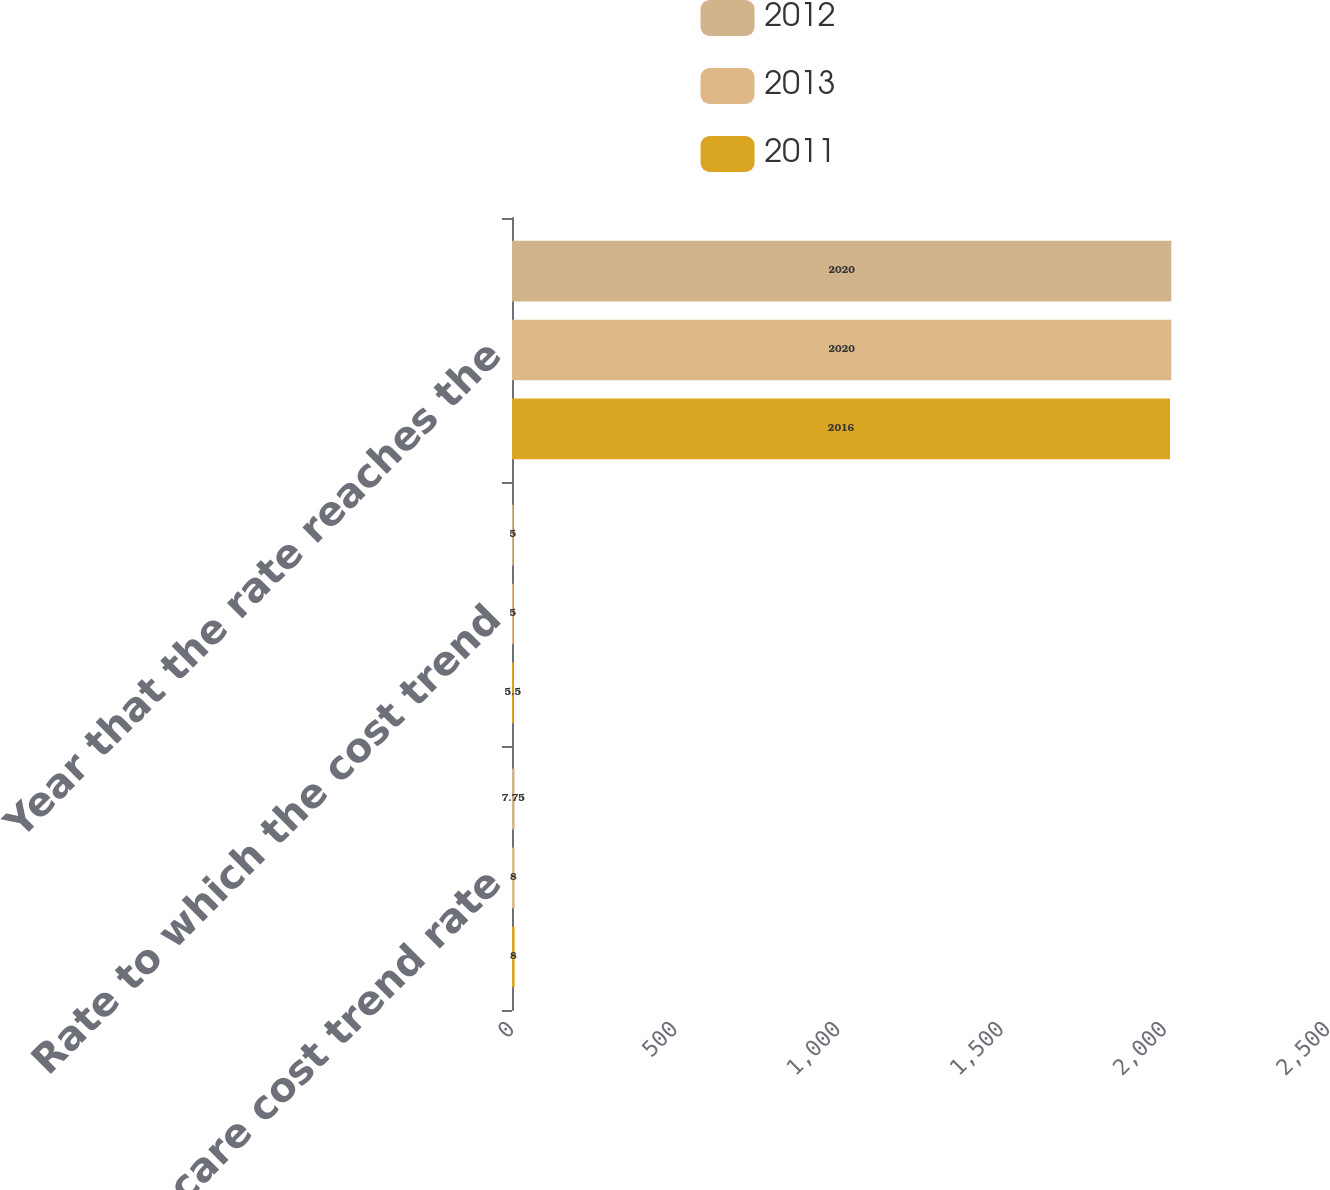Convert chart. <chart><loc_0><loc_0><loc_500><loc_500><stacked_bar_chart><ecel><fcel>Health care cost trend rate<fcel>Rate to which the cost trend<fcel>Year that the rate reaches the<nl><fcel>2012<fcel>7.75<fcel>5<fcel>2020<nl><fcel>2013<fcel>8<fcel>5<fcel>2020<nl><fcel>2011<fcel>8<fcel>5.5<fcel>2016<nl></chart> 